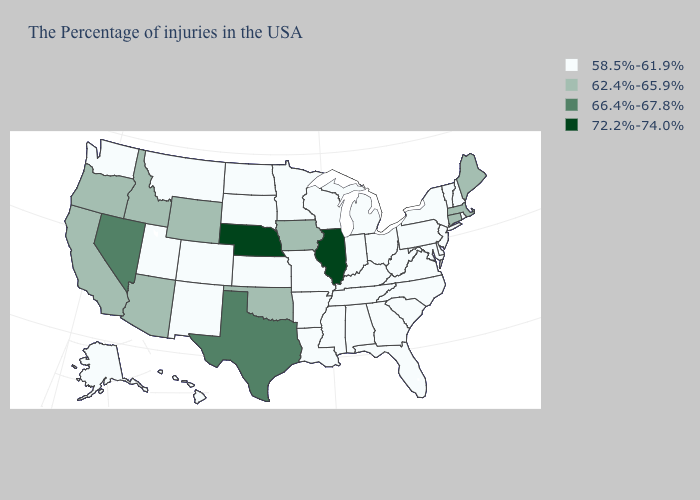Which states have the lowest value in the USA?
Give a very brief answer. Rhode Island, New Hampshire, Vermont, New York, New Jersey, Delaware, Maryland, Pennsylvania, Virginia, North Carolina, South Carolina, West Virginia, Ohio, Florida, Georgia, Michigan, Kentucky, Indiana, Alabama, Tennessee, Wisconsin, Mississippi, Louisiana, Missouri, Arkansas, Minnesota, Kansas, South Dakota, North Dakota, Colorado, New Mexico, Utah, Montana, Washington, Alaska, Hawaii. What is the value of Louisiana?
Write a very short answer. 58.5%-61.9%. Among the states that border New York , which have the highest value?
Give a very brief answer. Massachusetts, Connecticut. Does Vermont have the lowest value in the Northeast?
Give a very brief answer. Yes. What is the value of Missouri?
Quick response, please. 58.5%-61.9%. Which states hav the highest value in the West?
Give a very brief answer. Nevada. Name the states that have a value in the range 58.5%-61.9%?
Give a very brief answer. Rhode Island, New Hampshire, Vermont, New York, New Jersey, Delaware, Maryland, Pennsylvania, Virginia, North Carolina, South Carolina, West Virginia, Ohio, Florida, Georgia, Michigan, Kentucky, Indiana, Alabama, Tennessee, Wisconsin, Mississippi, Louisiana, Missouri, Arkansas, Minnesota, Kansas, South Dakota, North Dakota, Colorado, New Mexico, Utah, Montana, Washington, Alaska, Hawaii. What is the value of Texas?
Write a very short answer. 66.4%-67.8%. What is the highest value in the West ?
Keep it brief. 66.4%-67.8%. What is the value of Colorado?
Write a very short answer. 58.5%-61.9%. Does California have the lowest value in the USA?
Short answer required. No. What is the lowest value in states that border Missouri?
Be succinct. 58.5%-61.9%. What is the value of Vermont?
Answer briefly. 58.5%-61.9%. Is the legend a continuous bar?
Keep it brief. No. 